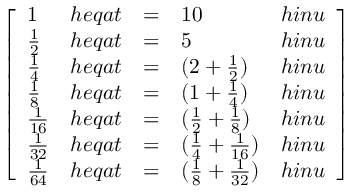<formula> <loc_0><loc_0><loc_500><loc_500>{ \left [ \begin{array} { l l l l l } { 1 } & { h e q a t } & { = } & { 1 0 } & { h i n u } \\ { { \frac { 1 } { 2 } } } & { h e q a t } & { = } & { 5 } & { h i n u } \\ { { \frac { 1 } { 4 } } } & { h e q a t } & { = } & { ( 2 + { \frac { 1 } { 2 } } ) } & { h i n u } \\ { { \frac { 1 } { 8 } } } & { h e q a t } & { = } & { ( 1 + { \frac { 1 } { 4 } } ) } & { h i n u } \\ { { \frac { 1 } { 1 6 } } } & { h e q a t } & { = } & { ( { \frac { 1 } { 2 } } + { \frac { 1 } { 8 } } ) } & { h i n u } \\ { { \frac { 1 } { 3 2 } } } & { h e q a t } & { = } & { ( { \frac { 1 } { 4 } } + { \frac { 1 } { 1 6 } } ) } & { h i n u } \\ { { \frac { 1 } { 6 4 } } } & { h e q a t } & { = } & { ( { \frac { 1 } { 8 } } + { \frac { 1 } { 3 2 } } ) } & { h i n u } \end{array} \right ] }</formula> 